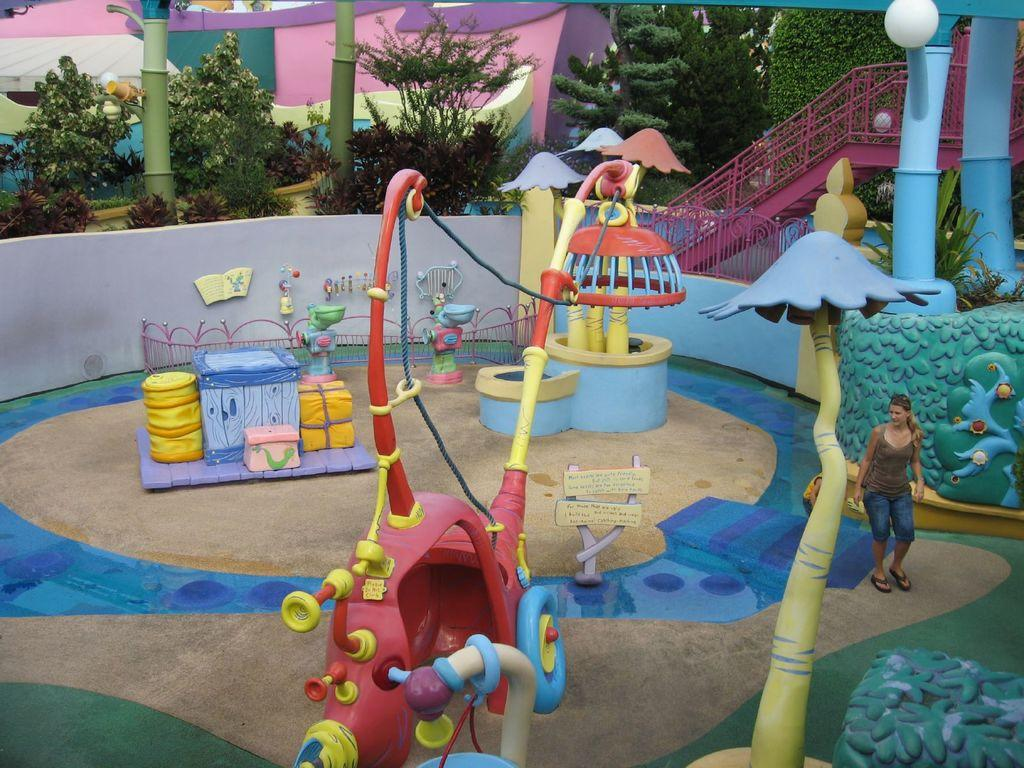What is the main subject of the image? There is a woman standing in the image. What are the kids doing around the woman? The kids are playing with equipment around the woman. What can be seen behind the woman? There are pillars with lamps behind the woman. What type of barrier is visible in the image? There is a metal rod fence visible in the image. What can be seen in the background of the image? Trees and a house are present in the background of the image. What type of amusement ride is the woman operating in the image? There is no amusement ride present in the image; it features a woman standing with kids playing nearby. How many trucks can be seen in the image? There are no trucks visible in the image. 